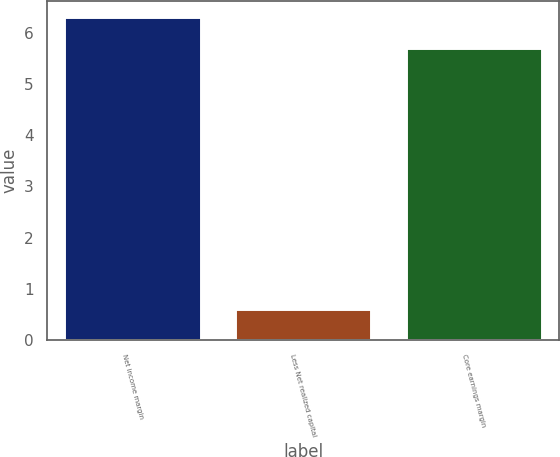<chart> <loc_0><loc_0><loc_500><loc_500><bar_chart><fcel>Net income margin<fcel>Less Net realized capital<fcel>Core earnings margin<nl><fcel>6.3<fcel>0.6<fcel>5.7<nl></chart> 